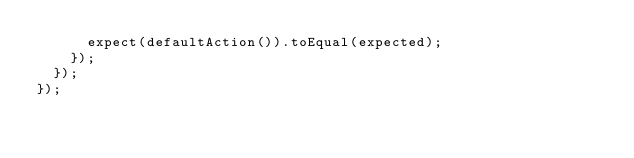<code> <loc_0><loc_0><loc_500><loc_500><_JavaScript_>      expect(defaultAction()).toEqual(expected);
    });
  });
});
</code> 